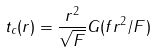Convert formula to latex. <formula><loc_0><loc_0><loc_500><loc_500>t _ { c } ( r ) = \frac { r ^ { 2 } } { \sqrt { F } } G ( { f r ^ { 2 } } / { F } )</formula> 